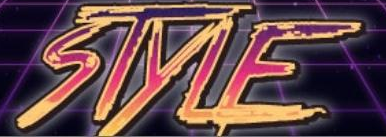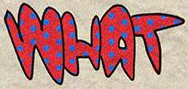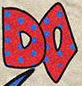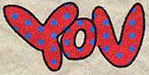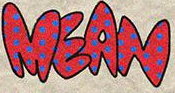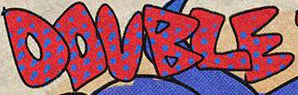What words are shown in these images in order, separated by a semicolon? STYLE; WHAT; DO; YOU; MEAN; DOUBLE 